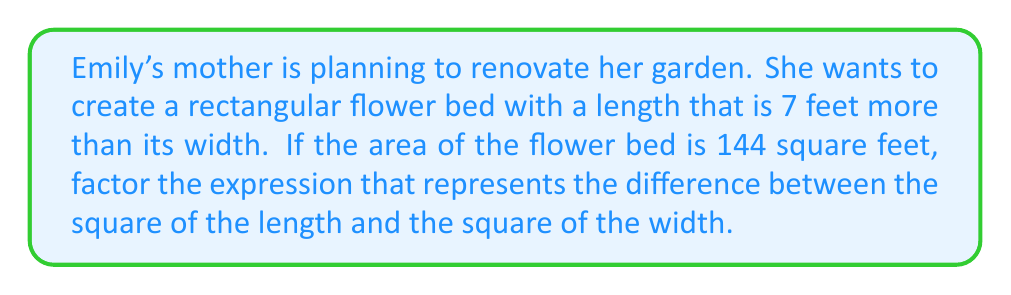Can you solve this math problem? Let's approach this step-by-step:

1) Let's define our variables:
   Let $w$ = width of the flower bed
   Then, $w + 7$ = length of the flower bed

2) We're told that the area is 144 square feet. We can express this as an equation:
   $w(w + 7) = 144$

3) Expand this equation:
   $w^2 + 7w = 144$

4) However, we're not asked to solve this equation. We're asked to factor the difference between the square of the length and the square of the width.

5) The expression for this difference is:
   $(w + 7)^2 - w^2$

6) This is in the form of a difference of two perfect squares: $a^2 - b^2$

7) The factoring formula for a difference of two perfect squares is:
   $a^2 - b^2 = (a+b)(a-b)$

8) In our case:
   $a = w + 7$
   $b = w$

9) Applying the formula:
   $((w + 7) + w)((w + 7) - w)$

10) Simplify:
    $(2w + 7)(7)$

Therefore, the factored expression is $(2w + 7)(7)$.
Answer: $(2w + 7)(7)$ 